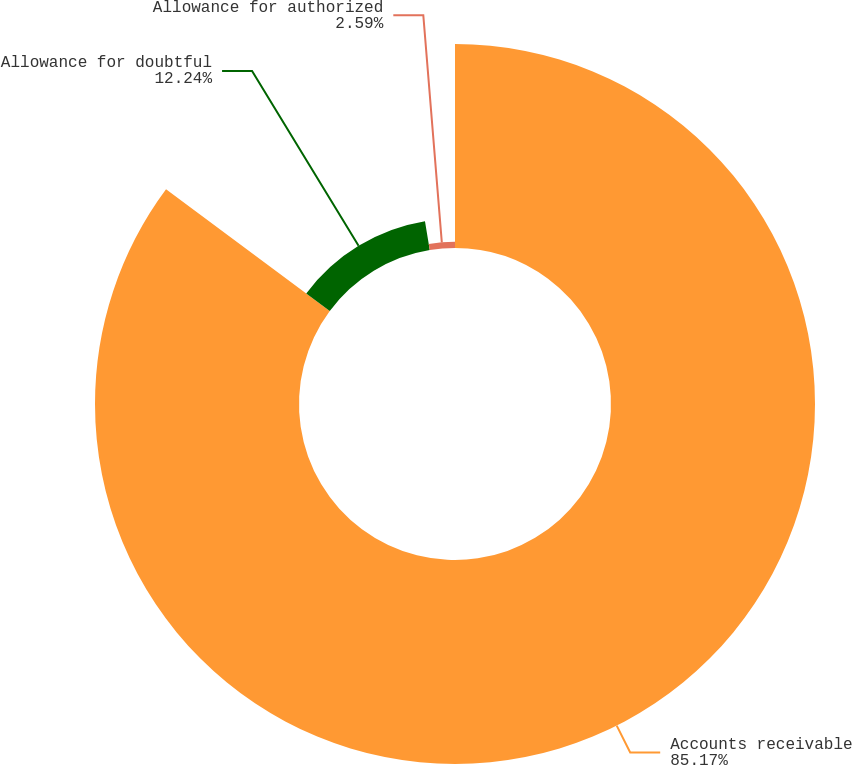Convert chart. <chart><loc_0><loc_0><loc_500><loc_500><pie_chart><fcel>Accounts receivable<fcel>Allowance for doubtful<fcel>Allowance for authorized<nl><fcel>85.17%<fcel>12.24%<fcel>2.59%<nl></chart> 